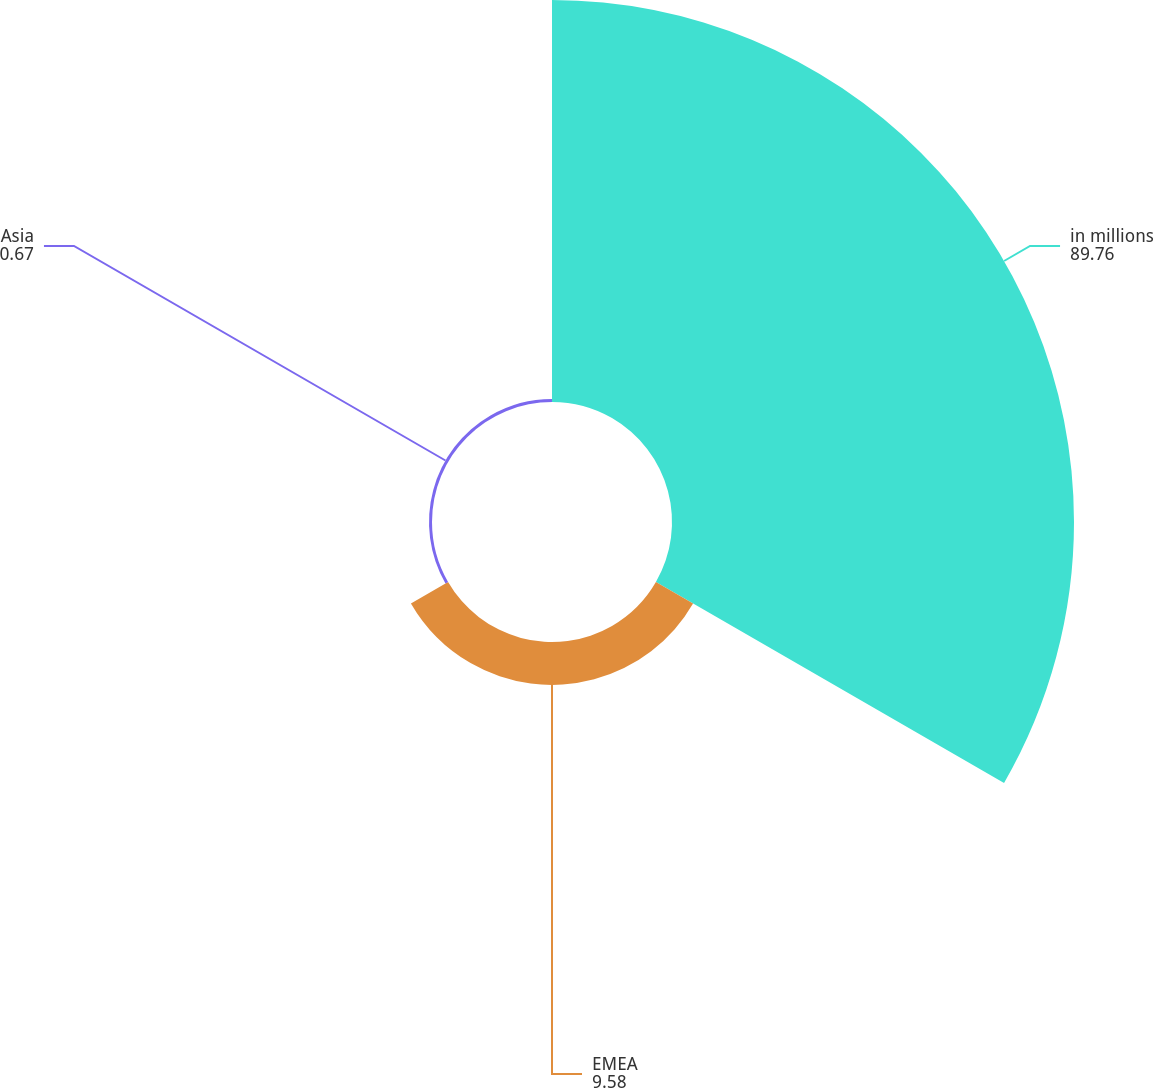Convert chart to OTSL. <chart><loc_0><loc_0><loc_500><loc_500><pie_chart><fcel>in millions<fcel>EMEA<fcel>Asia<nl><fcel>89.76%<fcel>9.58%<fcel>0.67%<nl></chart> 